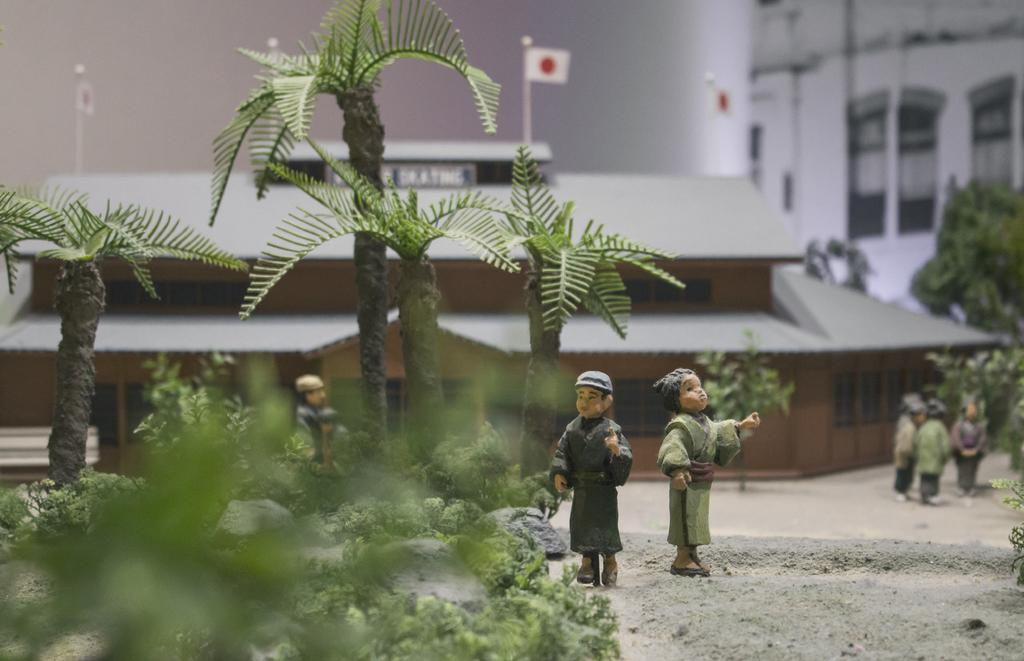What is the main subject of the image? The main subject of the image is a miniature. What types of objects can be found in the miniature? The miniature contains trees, plants, rocks, a road, people, a house, poles, flags, and a building. Can you describe the landscape in the miniature? The landscape in the miniature includes trees, plants, rocks, and a road. Are there any structures in the miniature? Yes, there is a house, poles, flags, and a building in the miniature. What type of sack is being used to carry the needles in the image? There is no sack or needles present in the image; it features a miniature with various objects and structures. What type of drink is being served at the event in the image? There is no event or drink present in the image; it features a miniature with various objects and structures. 